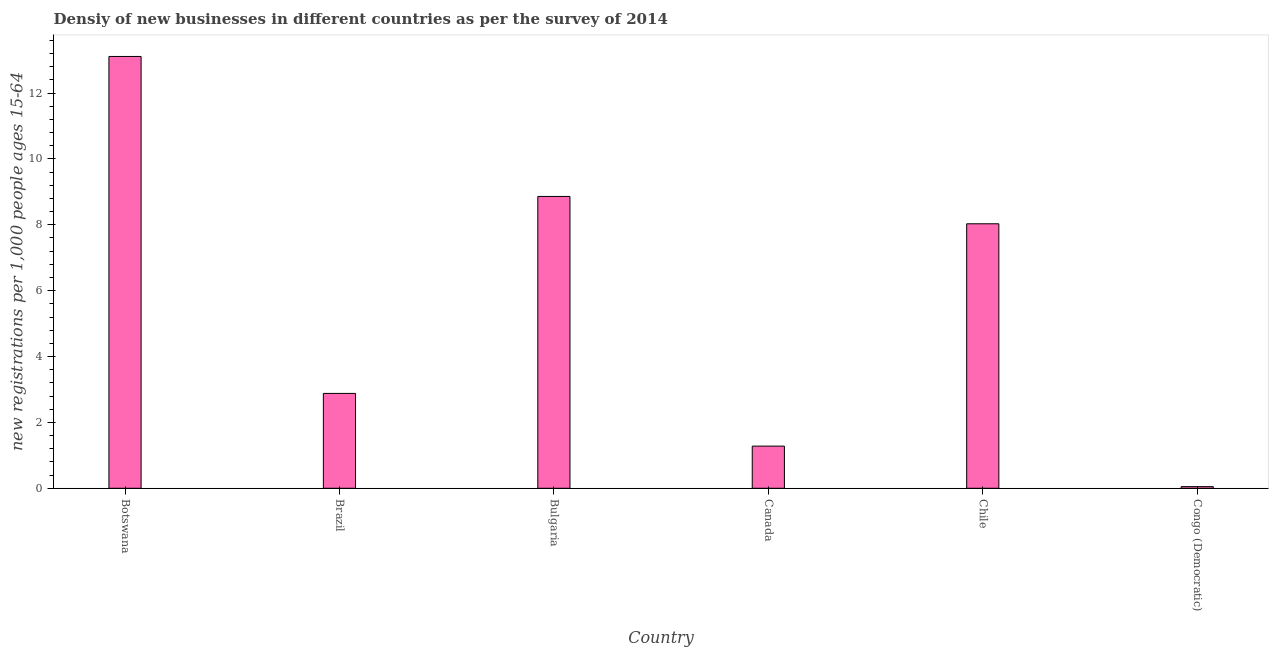What is the title of the graph?
Offer a very short reply. Densiy of new businesses in different countries as per the survey of 2014. What is the label or title of the X-axis?
Offer a very short reply. Country. What is the label or title of the Y-axis?
Your response must be concise. New registrations per 1,0 people ages 15-64. What is the density of new business in Chile?
Give a very brief answer. 8.03. Across all countries, what is the maximum density of new business?
Your answer should be very brief. 13.11. Across all countries, what is the minimum density of new business?
Make the answer very short. 0.05. In which country was the density of new business maximum?
Give a very brief answer. Botswana. In which country was the density of new business minimum?
Give a very brief answer. Congo (Democratic). What is the sum of the density of new business?
Give a very brief answer. 34.21. What is the difference between the density of new business in Bulgaria and Congo (Democratic)?
Give a very brief answer. 8.81. What is the average density of new business per country?
Provide a short and direct response. 5.7. What is the median density of new business?
Your answer should be very brief. 5.46. What is the ratio of the density of new business in Botswana to that in Canada?
Your response must be concise. 10.24. Is the density of new business in Botswana less than that in Canada?
Your answer should be compact. No. Is the difference between the density of new business in Canada and Congo (Democratic) greater than the difference between any two countries?
Give a very brief answer. No. What is the difference between the highest and the second highest density of new business?
Keep it short and to the point. 4.25. Is the sum of the density of new business in Brazil and Canada greater than the maximum density of new business across all countries?
Provide a short and direct response. No. What is the difference between the highest and the lowest density of new business?
Keep it short and to the point. 13.06. What is the difference between two consecutive major ticks on the Y-axis?
Offer a very short reply. 2. Are the values on the major ticks of Y-axis written in scientific E-notation?
Ensure brevity in your answer.  No. What is the new registrations per 1,000 people ages 15-64 of Botswana?
Offer a very short reply. 13.11. What is the new registrations per 1,000 people ages 15-64 in Brazil?
Ensure brevity in your answer.  2.88. What is the new registrations per 1,000 people ages 15-64 of Bulgaria?
Your answer should be very brief. 8.86. What is the new registrations per 1,000 people ages 15-64 in Canada?
Provide a succinct answer. 1.28. What is the new registrations per 1,000 people ages 15-64 in Chile?
Ensure brevity in your answer.  8.03. What is the difference between the new registrations per 1,000 people ages 15-64 in Botswana and Brazil?
Make the answer very short. 10.23. What is the difference between the new registrations per 1,000 people ages 15-64 in Botswana and Bulgaria?
Your response must be concise. 4.25. What is the difference between the new registrations per 1,000 people ages 15-64 in Botswana and Canada?
Provide a succinct answer. 11.83. What is the difference between the new registrations per 1,000 people ages 15-64 in Botswana and Chile?
Your answer should be compact. 5.08. What is the difference between the new registrations per 1,000 people ages 15-64 in Botswana and Congo (Democratic)?
Keep it short and to the point. 13.06. What is the difference between the new registrations per 1,000 people ages 15-64 in Brazil and Bulgaria?
Keep it short and to the point. -5.98. What is the difference between the new registrations per 1,000 people ages 15-64 in Brazil and Chile?
Offer a terse response. -5.15. What is the difference between the new registrations per 1,000 people ages 15-64 in Brazil and Congo (Democratic)?
Give a very brief answer. 2.83. What is the difference between the new registrations per 1,000 people ages 15-64 in Bulgaria and Canada?
Ensure brevity in your answer.  7.58. What is the difference between the new registrations per 1,000 people ages 15-64 in Bulgaria and Chile?
Offer a terse response. 0.83. What is the difference between the new registrations per 1,000 people ages 15-64 in Bulgaria and Congo (Democratic)?
Give a very brief answer. 8.81. What is the difference between the new registrations per 1,000 people ages 15-64 in Canada and Chile?
Offer a terse response. -6.75. What is the difference between the new registrations per 1,000 people ages 15-64 in Canada and Congo (Democratic)?
Provide a short and direct response. 1.23. What is the difference between the new registrations per 1,000 people ages 15-64 in Chile and Congo (Democratic)?
Your answer should be very brief. 7.98. What is the ratio of the new registrations per 1,000 people ages 15-64 in Botswana to that in Brazil?
Your response must be concise. 4.55. What is the ratio of the new registrations per 1,000 people ages 15-64 in Botswana to that in Bulgaria?
Offer a terse response. 1.48. What is the ratio of the new registrations per 1,000 people ages 15-64 in Botswana to that in Canada?
Keep it short and to the point. 10.24. What is the ratio of the new registrations per 1,000 people ages 15-64 in Botswana to that in Chile?
Your answer should be compact. 1.63. What is the ratio of the new registrations per 1,000 people ages 15-64 in Botswana to that in Congo (Democratic)?
Offer a very short reply. 262.2. What is the ratio of the new registrations per 1,000 people ages 15-64 in Brazil to that in Bulgaria?
Ensure brevity in your answer.  0.33. What is the ratio of the new registrations per 1,000 people ages 15-64 in Brazil to that in Canada?
Your response must be concise. 2.25. What is the ratio of the new registrations per 1,000 people ages 15-64 in Brazil to that in Chile?
Your response must be concise. 0.36. What is the ratio of the new registrations per 1,000 people ages 15-64 in Brazil to that in Congo (Democratic)?
Provide a short and direct response. 57.6. What is the ratio of the new registrations per 1,000 people ages 15-64 in Bulgaria to that in Canada?
Keep it short and to the point. 6.92. What is the ratio of the new registrations per 1,000 people ages 15-64 in Bulgaria to that in Chile?
Give a very brief answer. 1.1. What is the ratio of the new registrations per 1,000 people ages 15-64 in Bulgaria to that in Congo (Democratic)?
Your response must be concise. 177.2. What is the ratio of the new registrations per 1,000 people ages 15-64 in Canada to that in Chile?
Offer a very short reply. 0.16. What is the ratio of the new registrations per 1,000 people ages 15-64 in Canada to that in Congo (Democratic)?
Offer a very short reply. 25.6. What is the ratio of the new registrations per 1,000 people ages 15-64 in Chile to that in Congo (Democratic)?
Your response must be concise. 160.6. 